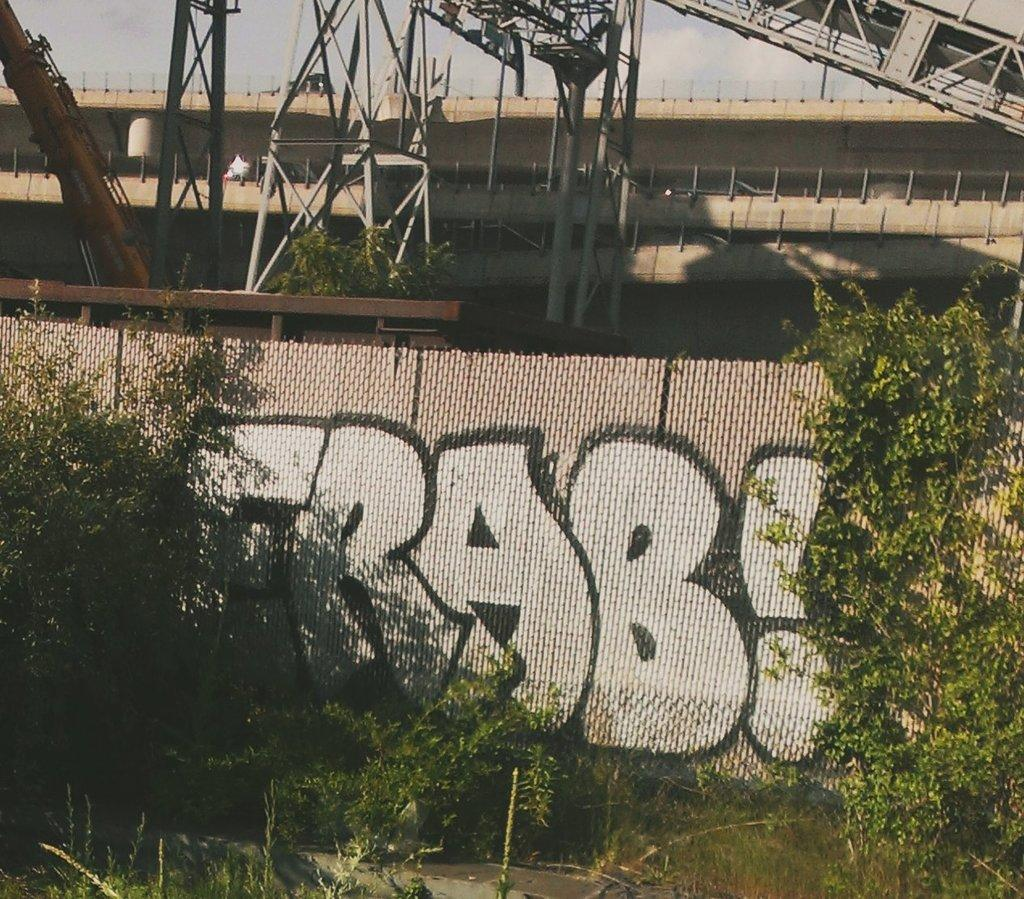What type of structure is visible in the image? There is a building in the image. What other natural elements can be seen in the image? There are trees and plants visible in the image. What architectural features are present in the image? There are towers and a wall visible in the image. What is being used for construction in the image? There is a crane in the image. What can be seen in the background of the image? The sky with clouds is visible in the background of the image. Can you tell me how many turkeys are visible in the image? There are no turkeys present in the image. What type of joke is being told by the trees in the image? There are no jokes being told by the trees in the image; they are simply trees. 